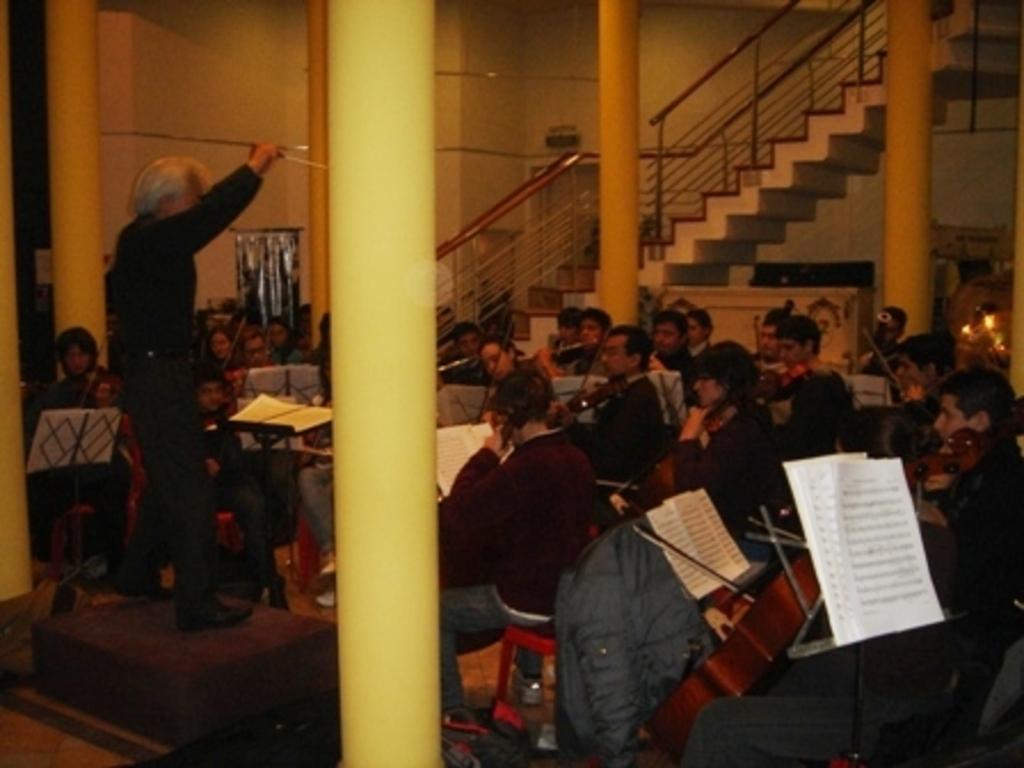Can you describe this image briefly? In this image we can see pillars, stairs, chairs, persons, books. In the background there is wall. 